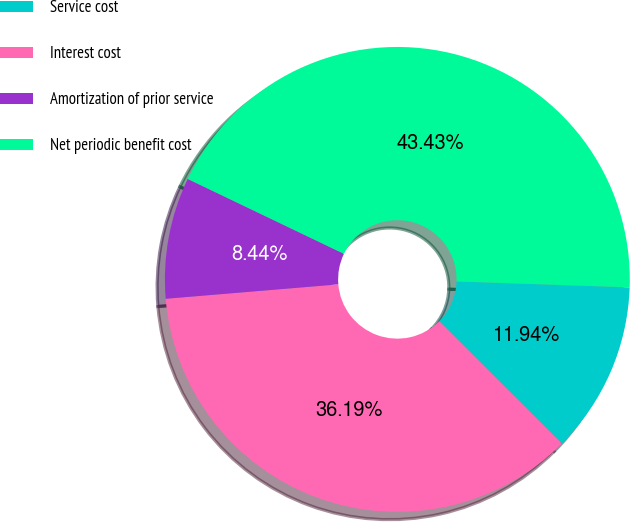Convert chart to OTSL. <chart><loc_0><loc_0><loc_500><loc_500><pie_chart><fcel>Service cost<fcel>Interest cost<fcel>Amortization of prior service<fcel>Net periodic benefit cost<nl><fcel>11.94%<fcel>36.19%<fcel>8.44%<fcel>43.43%<nl></chart> 